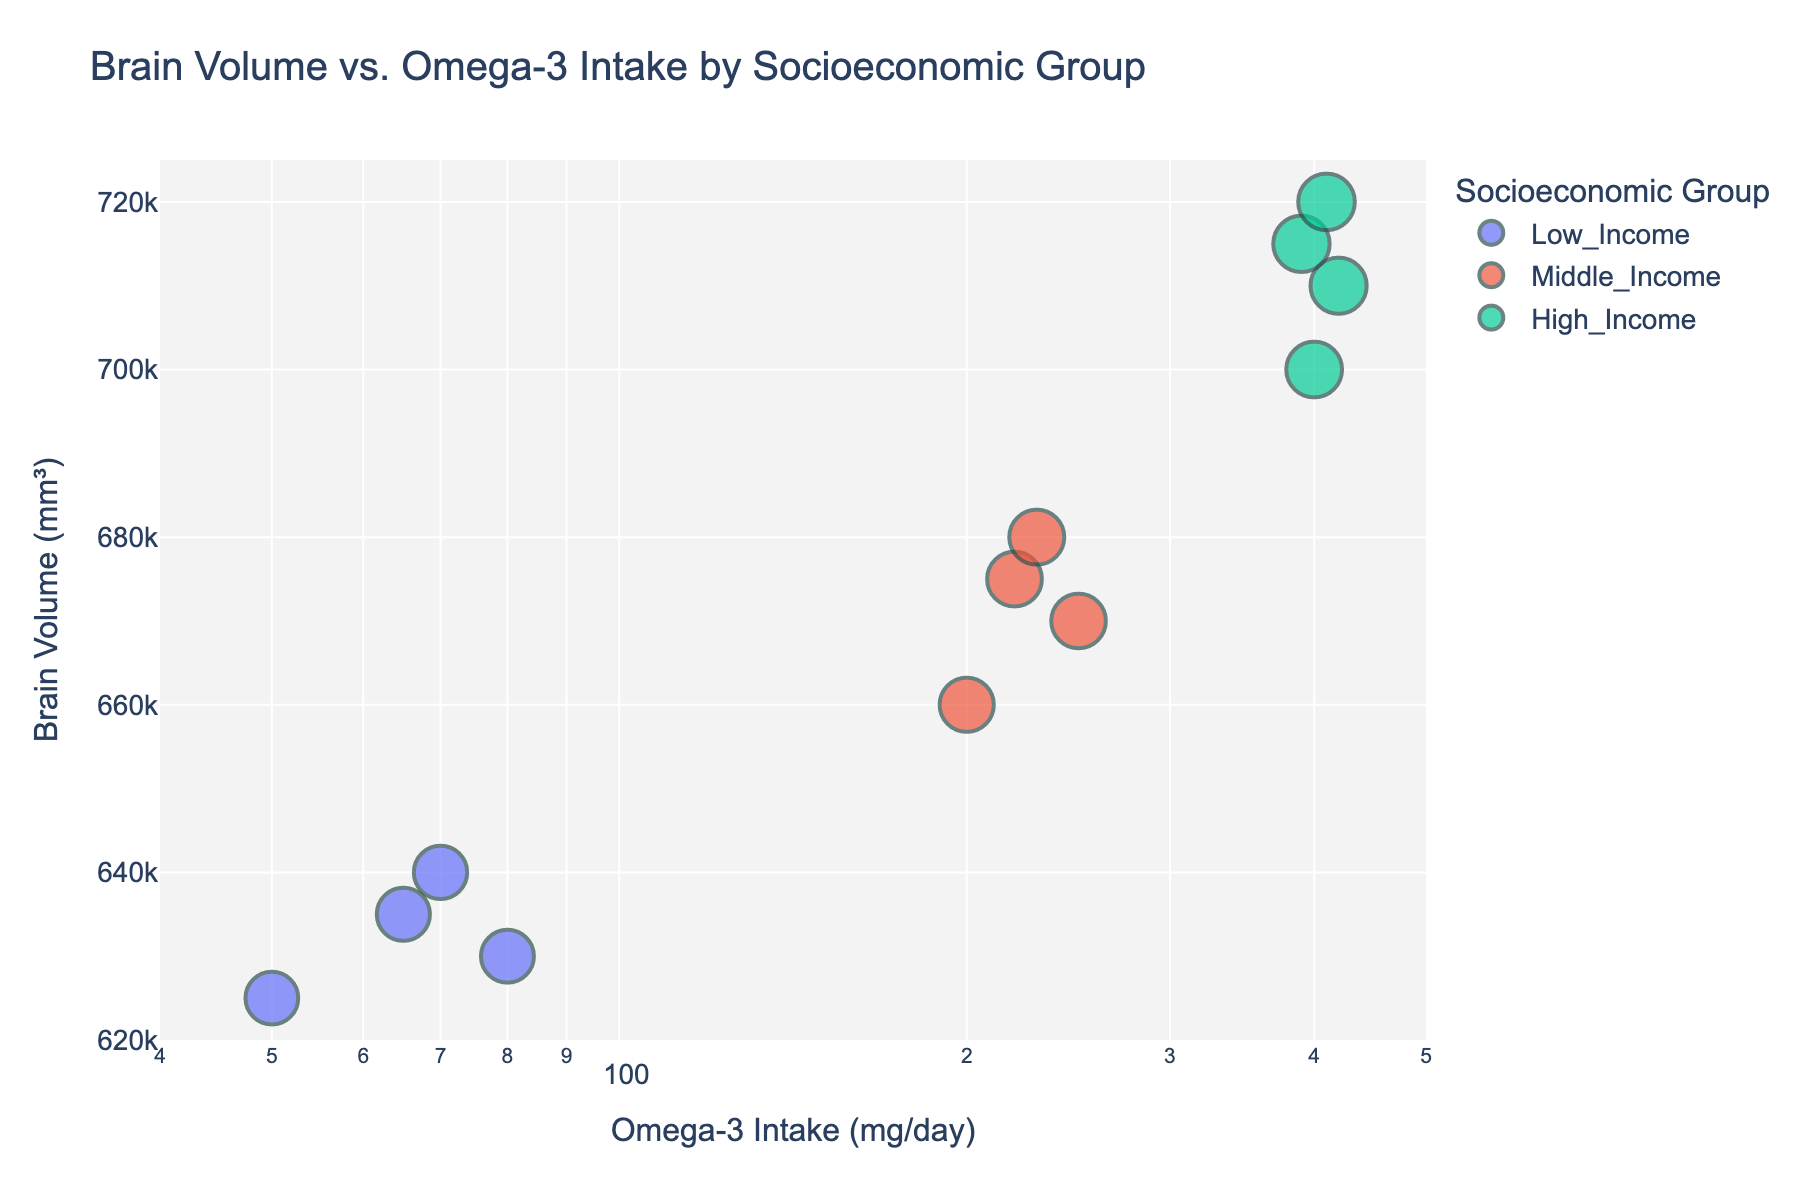How many socioeconomic groups are represented in the figure? The title and legend of the figure indicate there are distinct socioeconomic groups represented. By examining the legend colors, we can see there are three groups: Low Income, Middle Income, and High Income.
Answer: 3 What is the title of the figure? The title is usually found at the top of the figure. In this case, it reads "Brain Volume vs. Omega-3 Intake by Socioeconomic Group".
Answer: "Brain Volume vs. Omega-3 Intake by Socioeconomic Group" Which socioeconomic group has the highest omega-3 intake value? By observing the x-axis positions of the scatter points, the High Income group has data points on the far right side, indicating the highest omega-3 intake values.
Answer: High Income What is the approximate range of brain volumes for the Low Income group? The data points for the Low Income group are found between 625,000 mm³ and 640,000 mm³ on the y-axis.
Answer: 625,000 to 640,000 mm³ Which socioeconomic group exhibits the greatest variability in brain volume measurements? By comparing the spread of data points on the y-axis across groups, the Middle Income group shows a wider spread (660,000 to 680,000 mm³) as compared to Low Income and High Income groups.
Answer: Middle Income What is the approximate median omega-3 intake for the Middle Income group? The Middle Income group has omega-3 intake values: 200, 220, 230, 250. Sorting these: 200, 220, 230, 250, so the median is the average of 220 and 230, which is (220+230)/2 = 225 mg/day.
Answer: 225 mg/day How does the brain volume measurement change with omega-3 intake in the High Income group? Observing the scatter points for the High Income group, they generally show an upward trend, indicating that higher omega-3 intake correlates with increased brain volume.
Answer: Increases Which group has the least variance in omega-3 intake? By examining the spread of omega-3 intake values (x-axis), the Low Income group has the smallest range (50 to 80 mg/day), showing the least variance.
Answer: Low Income What is the average brain volume for the High Income group? The brain volumes for High Income are 700,000, 710,000, 715,000, 720,000. Adding these gives 2,845,000 mm³, and averaging (2,845,000/4 = 711,250 mm³).
Answer: 711,250 mm³ Are there any outliers in the omega-3 intake within any socioeconomic group? Comparing the data points to typical ranges within each group, no single data point significantly deviates from its group trend, indicating no outliers.
Answer: No 